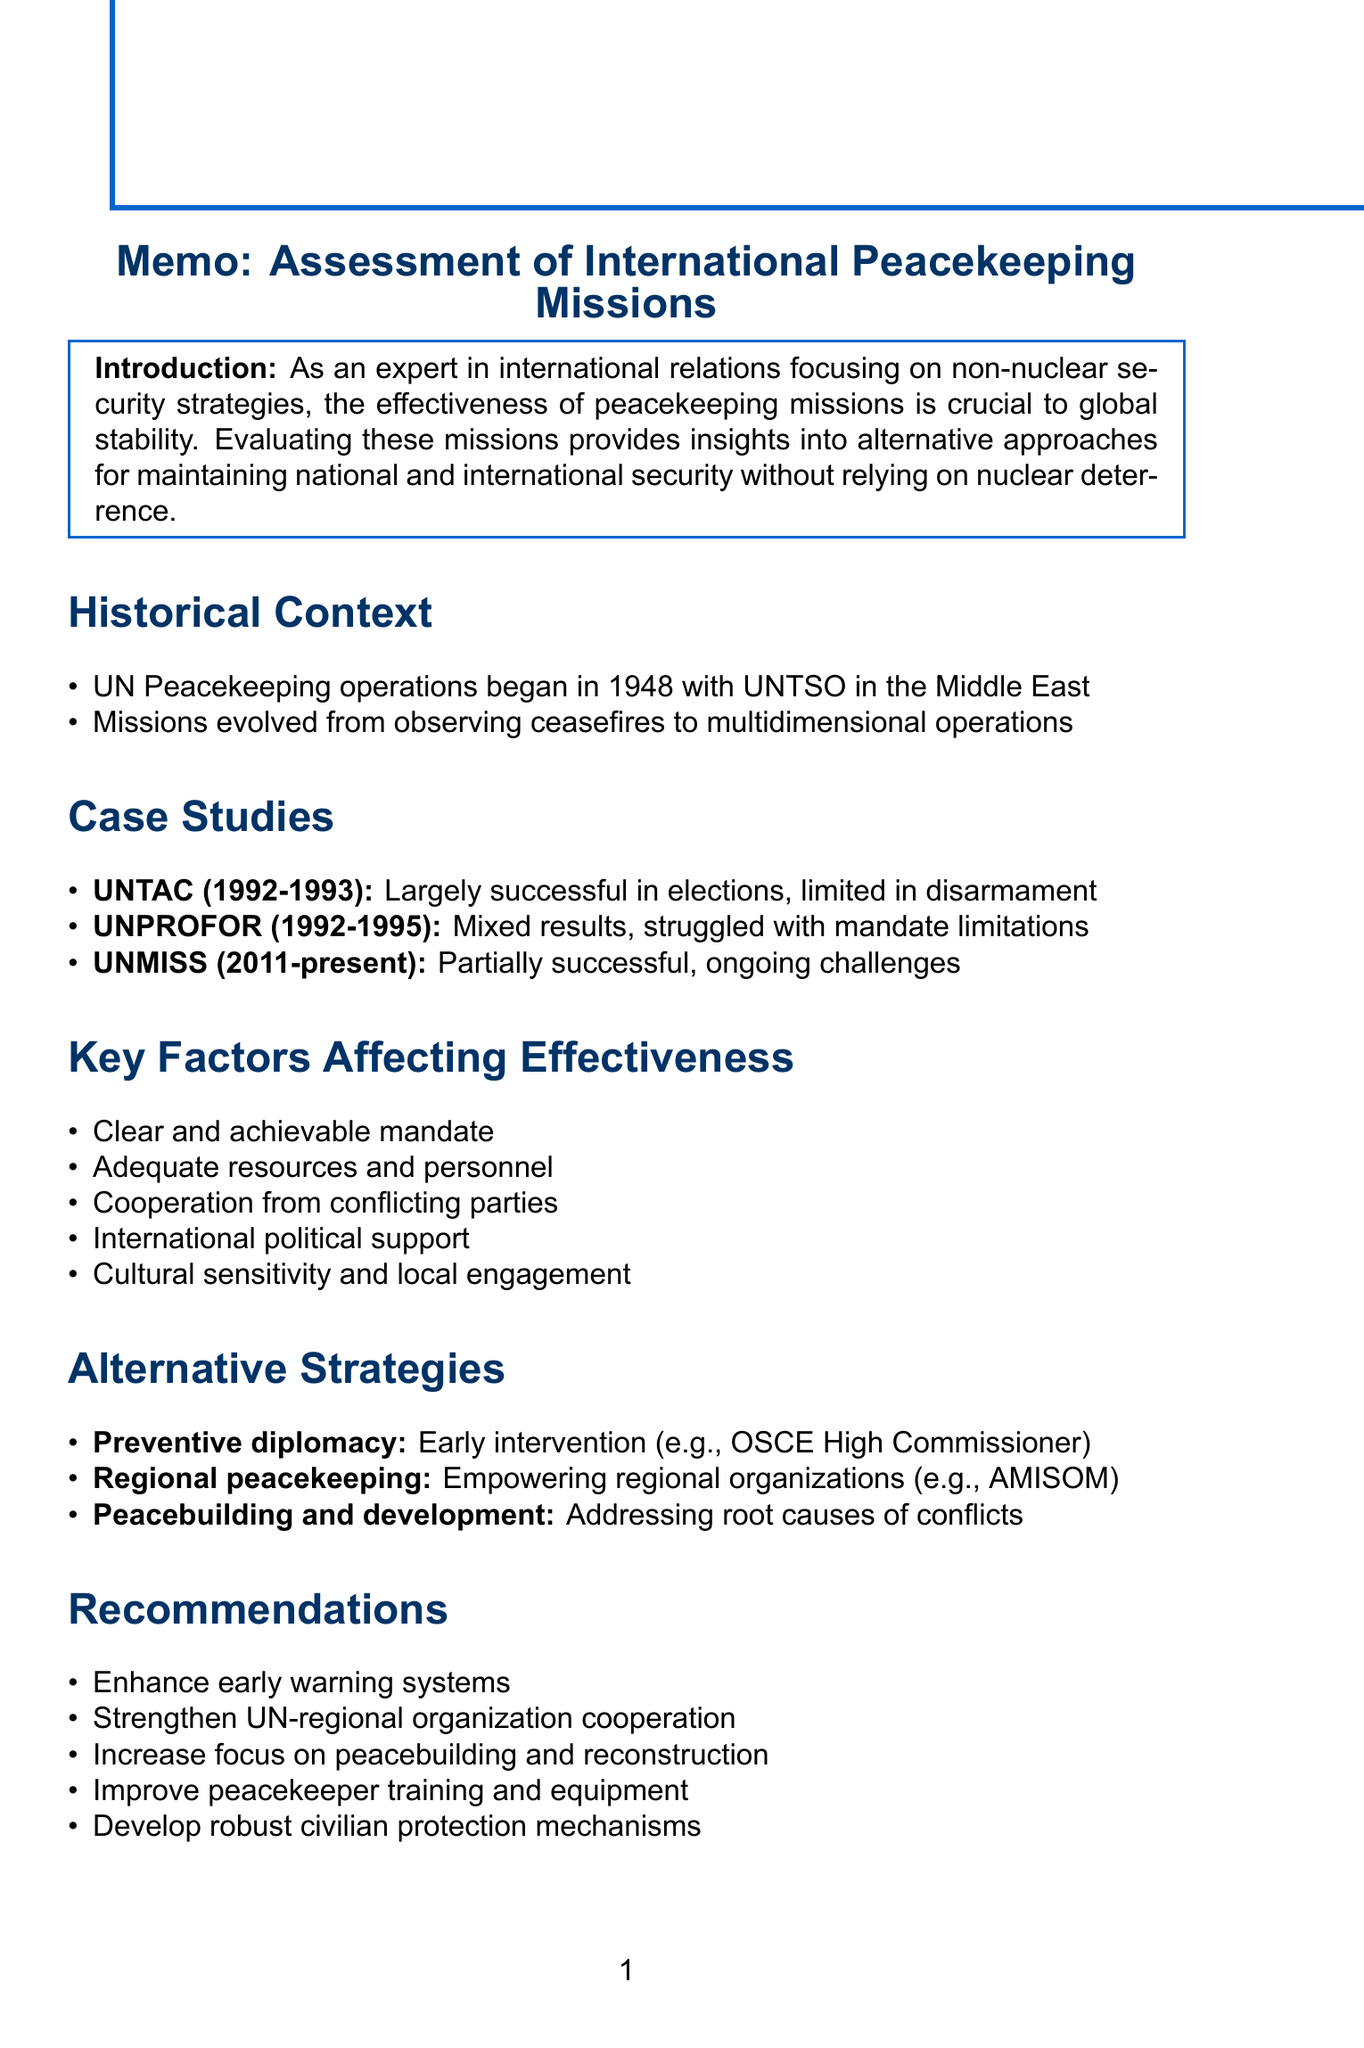What year did UN Peacekeeping operations begin? The document states that UN Peacekeeping operations started in 1948 with UNTSO in the Middle East.
Answer: 1948 What mission is referred to as UNTAC? The document refers to the United Nations Transitional Authority in Cambodia as UNTAC.
Answer: United Nations Transitional Authority in Cambodia What was a challenge faced by UNPROFOR? The document notes that UNPROFOR struggled with mandate limitations as a challenge.
Answer: Mandate limitations What is a key factor affecting the effectiveness of peacekeeping missions? The document lists several key factors; one example is the need for adequate resources and personnel.
Answer: Adequate resources and personnel What approach does the document suggest for early intervention? The document suggests preventive diplomacy as an approach for early intervention.
Answer: Preventive diplomacy How many case studies are mentioned in the document? The document lists three case studies related to peacekeeping missions.
Answer: Three What recommendation is made regarding peacekeeper training? The document recommends improving training and equipment for peacekeepers.
Answer: Improve training and equipment What is the time span of the UNMISS mission? The document states that the UNMISS mission has been ongoing since 2011.
Answer: 2011-present What does the document conclude about peacekeeping missions? The conclusion expresses that peacekeeping missions are crucial for maintaining international peace.
Answer: Crucial for maintaining international peace 